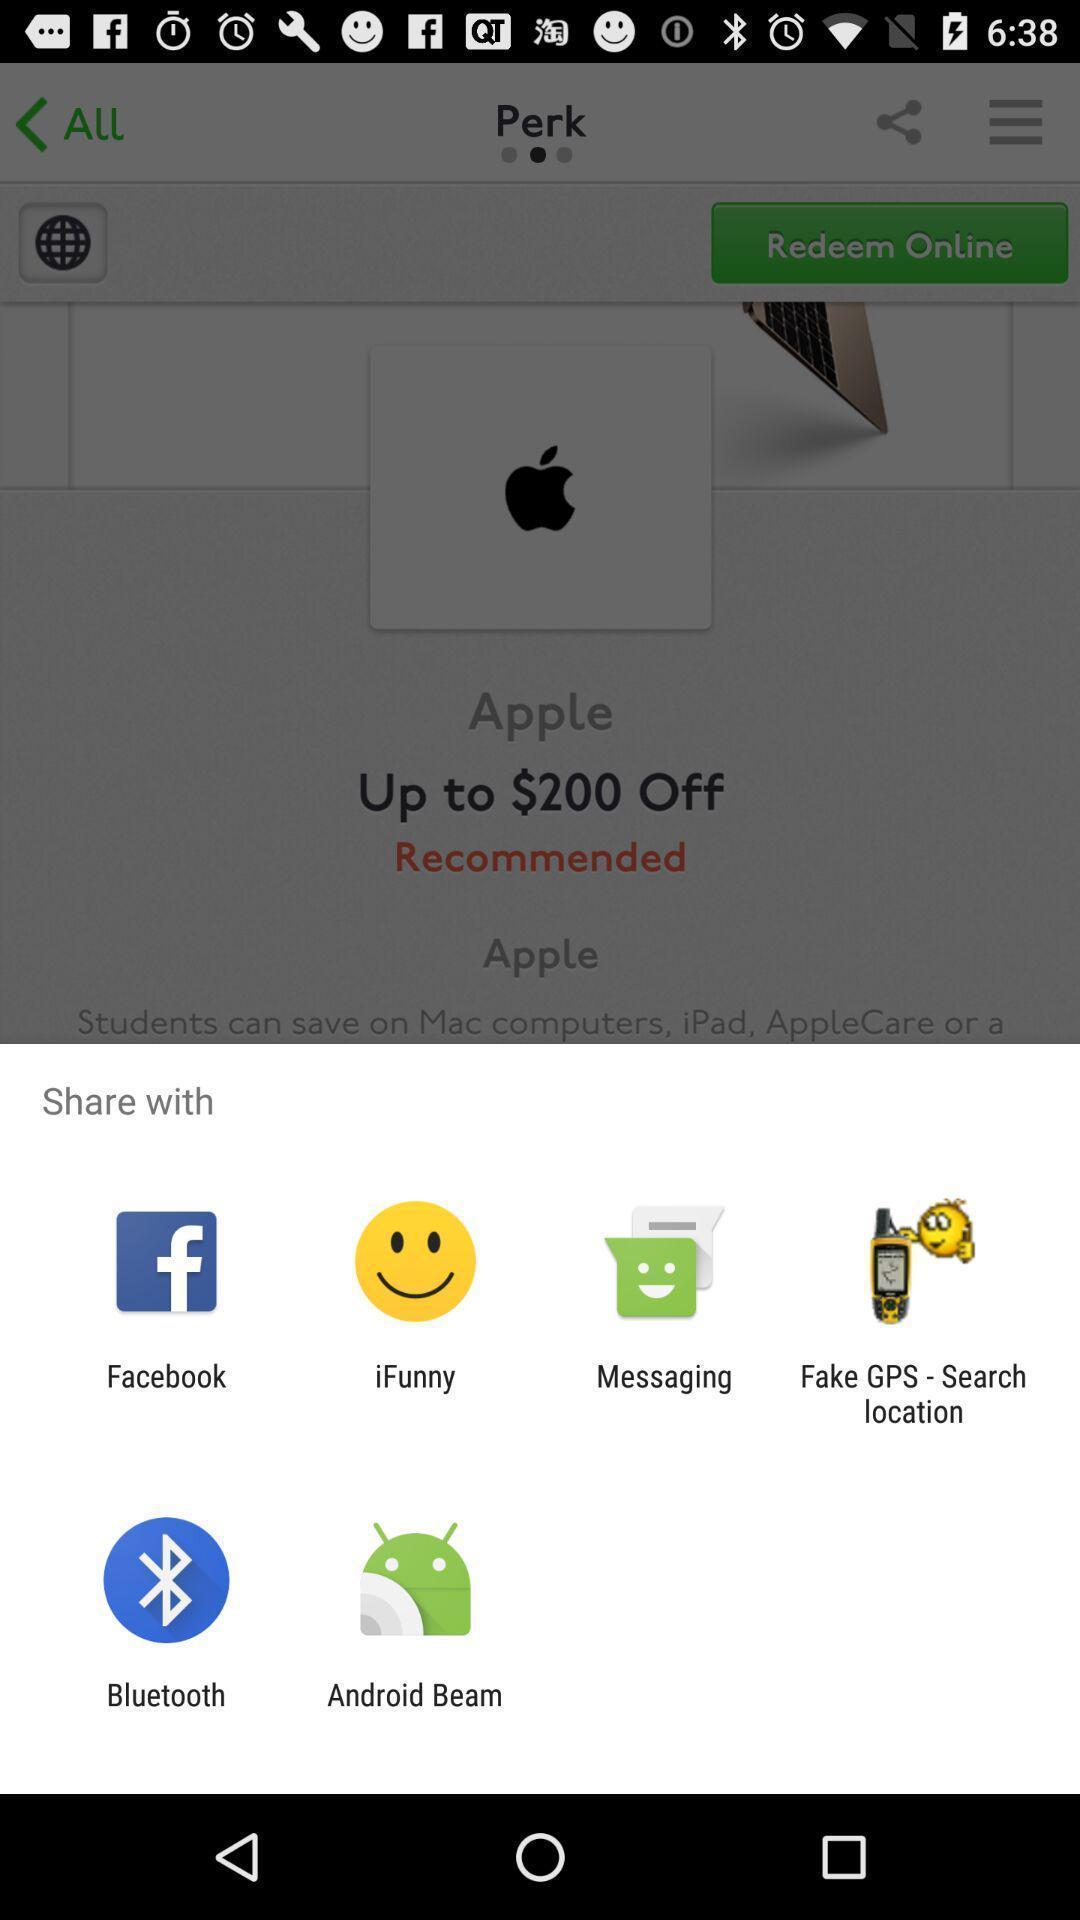Summarize the information in this screenshot. Share information with different apps. 